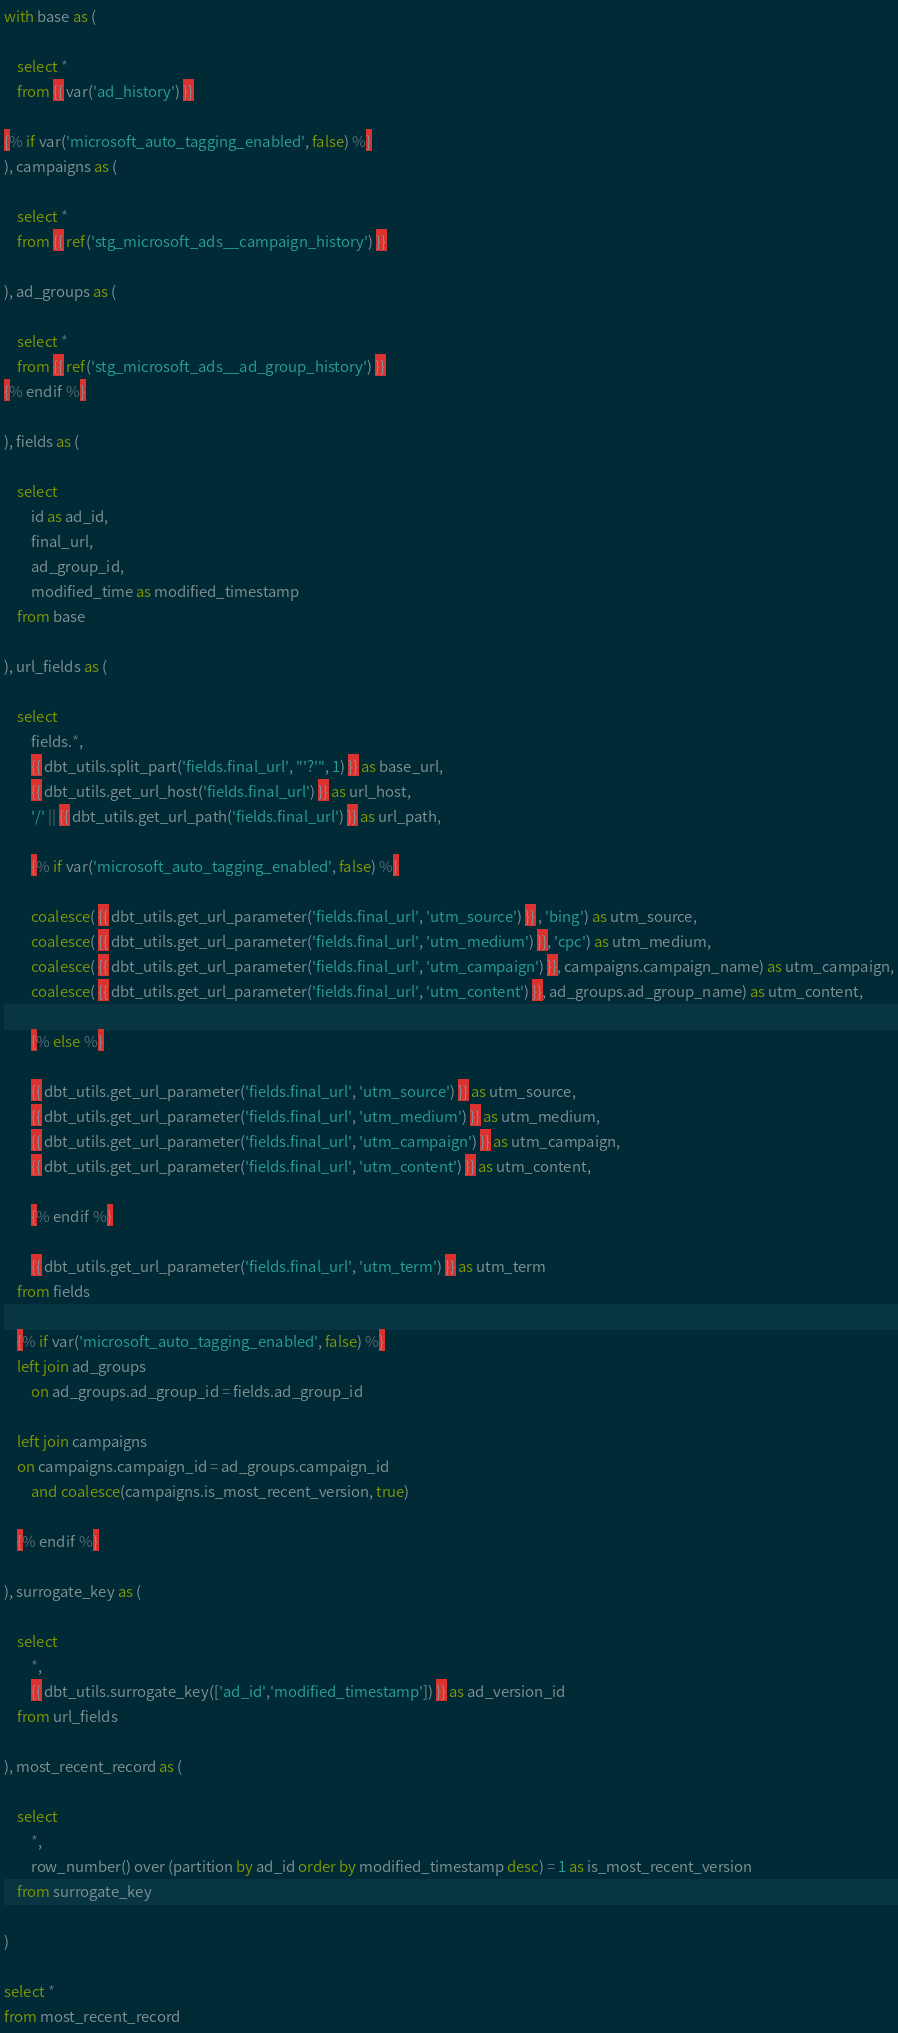<code> <loc_0><loc_0><loc_500><loc_500><_SQL_>with base as (

    select *
    from {{ var('ad_history') }}

{% if var('microsoft_auto_tagging_enabled', false) %}
), campaigns as (
    
    select * 
    from {{ ref('stg_microsoft_ads__campaign_history') }}

), ad_groups as (
    
    select *
    from {{ ref('stg_microsoft_ads__ad_group_history') }}
{% endif %}

), fields as (

    select 
        id as ad_id,
        final_url,
        ad_group_id,
        modified_time as modified_timestamp
    from base

), url_fields as (

    select 
        fields.*,
        {{ dbt_utils.split_part('fields.final_url', "'?'", 1) }} as base_url,
        {{ dbt_utils.get_url_host('fields.final_url') }} as url_host,
        '/' || {{ dbt_utils.get_url_path('fields.final_url') }} as url_path,

        {% if var('microsoft_auto_tagging_enabled', false) %}

        coalesce( {{ dbt_utils.get_url_parameter('fields.final_url', 'utm_source') }} , 'bing') as utm_source,
        coalesce( {{ dbt_utils.get_url_parameter('fields.final_url', 'utm_medium') }}, 'cpc') as utm_medium,
        coalesce( {{ dbt_utils.get_url_parameter('fields.final_url', 'utm_campaign') }}, campaigns.campaign_name) as utm_campaign,
        coalesce( {{ dbt_utils.get_url_parameter('fields.final_url', 'utm_content') }}, ad_groups.ad_group_name) as utm_content,

        {% else %}

        {{ dbt_utils.get_url_parameter('fields.final_url', 'utm_source') }} as utm_source,
        {{ dbt_utils.get_url_parameter('fields.final_url', 'utm_medium') }} as utm_medium,
        {{ dbt_utils.get_url_parameter('fields.final_url', 'utm_campaign') }} as utm_campaign,
        {{ dbt_utils.get_url_parameter('fields.final_url', 'utm_content') }} as utm_content,

        {% endif %}

        {{ dbt_utils.get_url_parameter('fields.final_url', 'utm_term') }} as utm_term
    from fields

    {% if var('microsoft_auto_tagging_enabled', false) %}
    left join ad_groups
        on ad_groups.ad_group_id = fields.ad_group_id

    left join campaigns
    on campaigns.campaign_id = ad_groups.campaign_id
        and coalesce(campaigns.is_most_recent_version, true)

    {% endif %}

), surrogate_key as (

    select 
        *,
        {{ dbt_utils.surrogate_key(['ad_id','modified_timestamp']) }} as ad_version_id
    from url_fields

), most_recent_record as (

    select
        *,
        row_number() over (partition by ad_id order by modified_timestamp desc) = 1 as is_most_recent_version
    from surrogate_key

)

select *
from most_recent_record</code> 